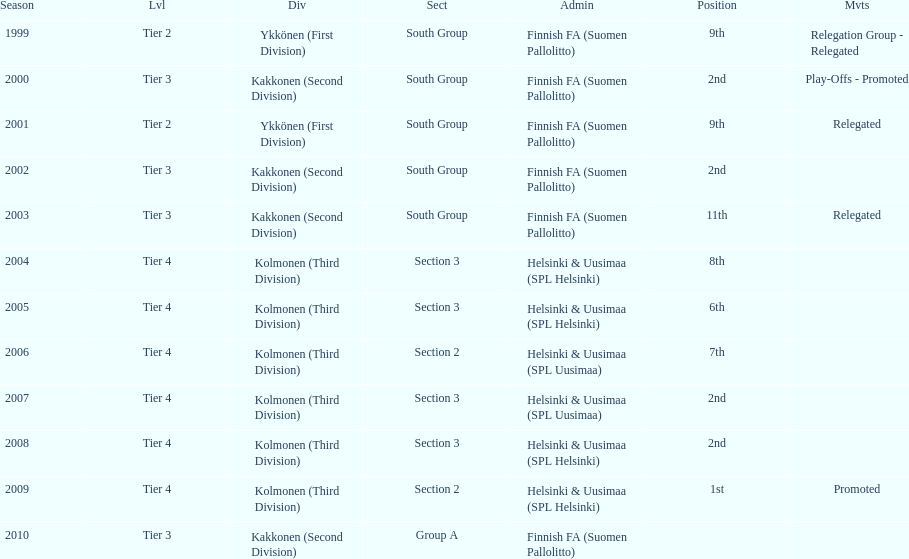What position did this team get after getting 9th place in 1999? 2nd. 